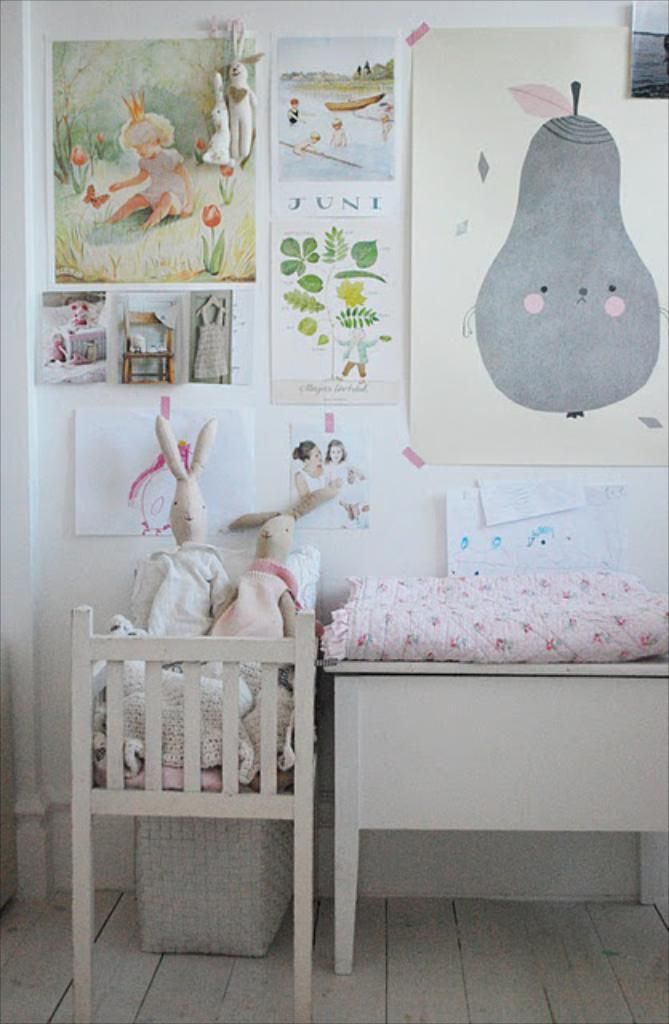What is the main object in the image? There is a cradle in the image. What can be seen on the cradle? There are 2 soft toys on the cradle. What other piece of furniture is present in the image? There is a bed in the image. What can be seen on the wall in the background? There are paintings on the wall in the background. What part of the room is visible in the image? The floor is visible in the image. What type of thrill can be experienced by the soft toys in the image? The soft toys in the image are not experiencing any thrill; they are simply resting on the cradle. 